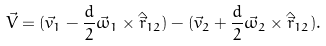<formula> <loc_0><loc_0><loc_500><loc_500>\vec { V } = ( \vec { v } _ { 1 } - \frac { d } { 2 } \vec { \omega } _ { 1 } \times \hat { \vec { r } } _ { 1 2 } ) - ( \vec { v } _ { 2 } + \frac { d } { 2 } \vec { \omega } _ { 2 } \times \hat { \vec { r } } _ { 1 2 } ) .</formula> 